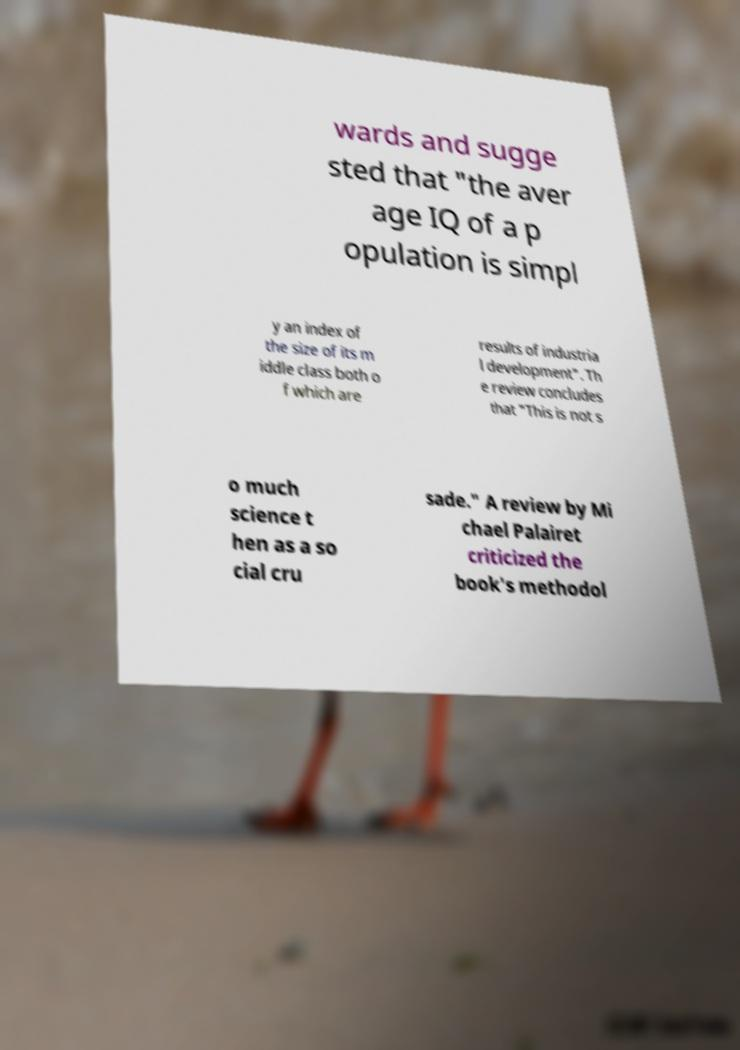There's text embedded in this image that I need extracted. Can you transcribe it verbatim? wards and sugge sted that "the aver age IQ of a p opulation is simpl y an index of the size of its m iddle class both o f which are results of industria l development". Th e review concludes that "This is not s o much science t hen as a so cial cru sade." A review by Mi chael Palairet criticized the book's methodol 